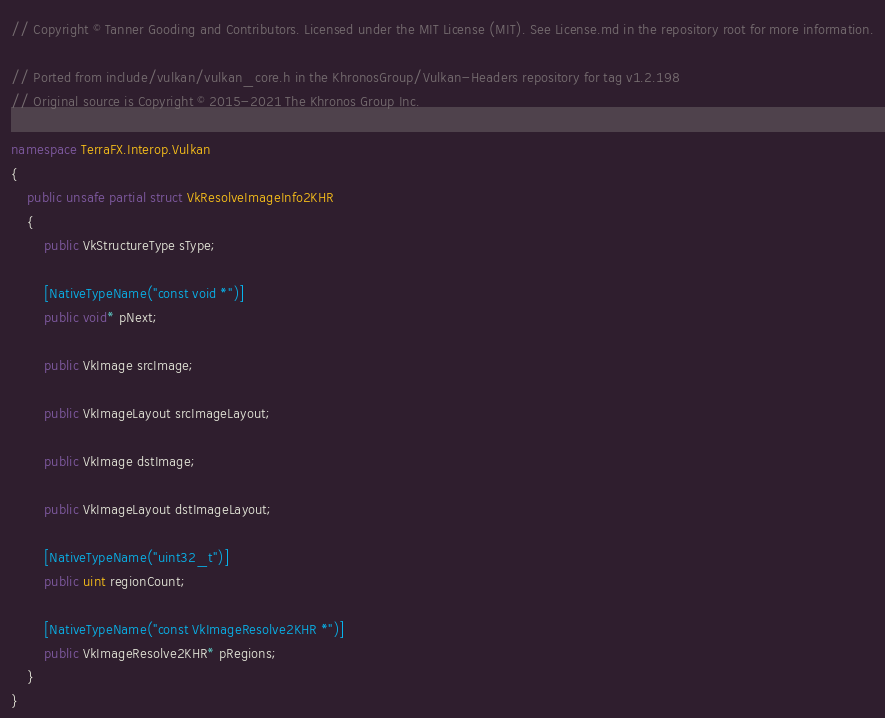Convert code to text. <code><loc_0><loc_0><loc_500><loc_500><_C#_>// Copyright © Tanner Gooding and Contributors. Licensed under the MIT License (MIT). See License.md in the repository root for more information.

// Ported from include/vulkan/vulkan_core.h in the KhronosGroup/Vulkan-Headers repository for tag v1.2.198
// Original source is Copyright © 2015-2021 The Khronos Group Inc.

namespace TerraFX.Interop.Vulkan
{
    public unsafe partial struct VkResolveImageInfo2KHR
    {
        public VkStructureType sType;

        [NativeTypeName("const void *")]
        public void* pNext;

        public VkImage srcImage;

        public VkImageLayout srcImageLayout;

        public VkImage dstImage;

        public VkImageLayout dstImageLayout;

        [NativeTypeName("uint32_t")]
        public uint regionCount;

        [NativeTypeName("const VkImageResolve2KHR *")]
        public VkImageResolve2KHR* pRegions;
    }
}
</code> 